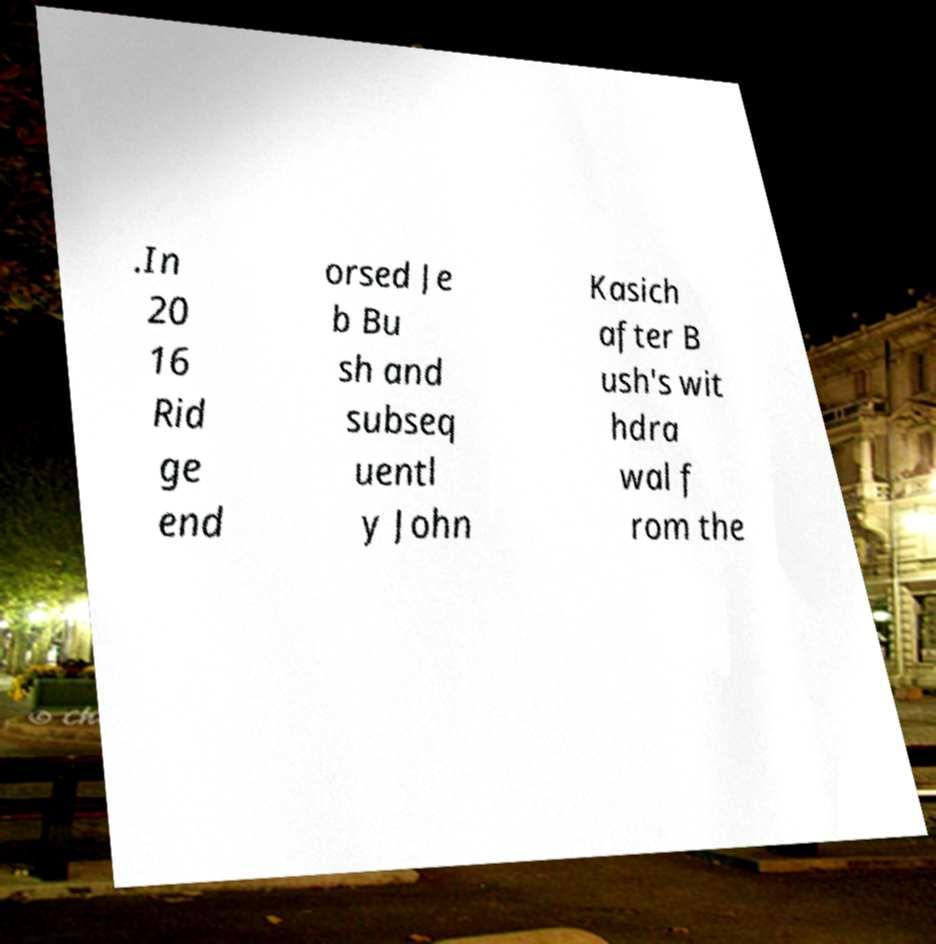For documentation purposes, I need the text within this image transcribed. Could you provide that? .In 20 16 Rid ge end orsed Je b Bu sh and subseq uentl y John Kasich after B ush's wit hdra wal f rom the 